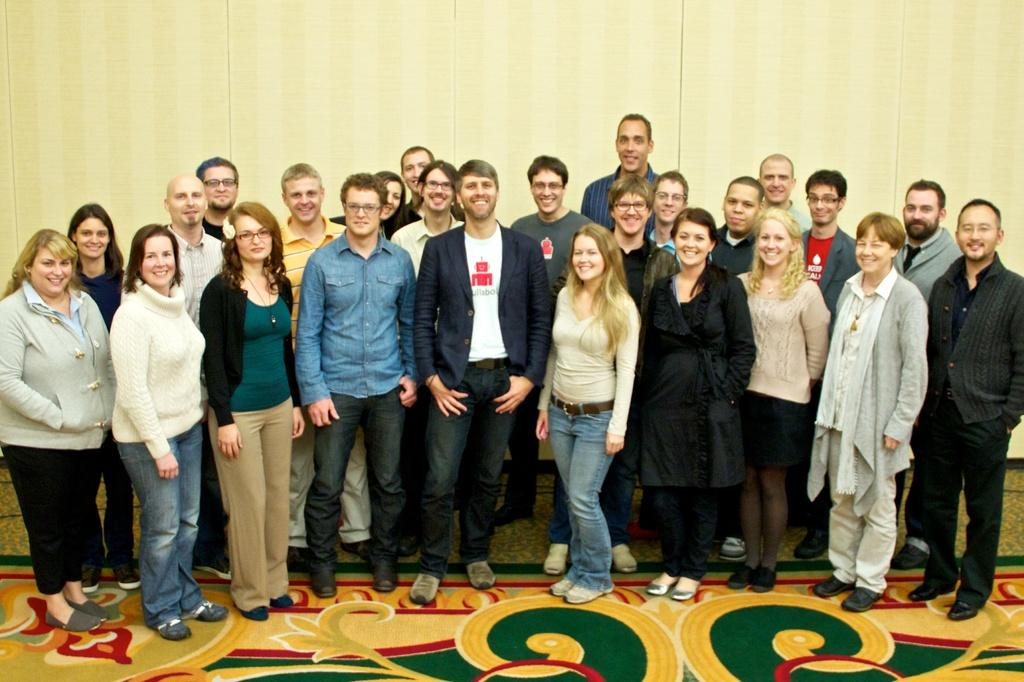What is happening in the image? There are people standing in the image. What is on the floor in the image? There is a carpet on the floor in the image. What can be seen in the background of the image? There is a wall visible in the background of the image. What type of current is flowing through the crook's device in the image? There is no crook or device present in the image, so it is not possible to determine what type of current might be flowing. 